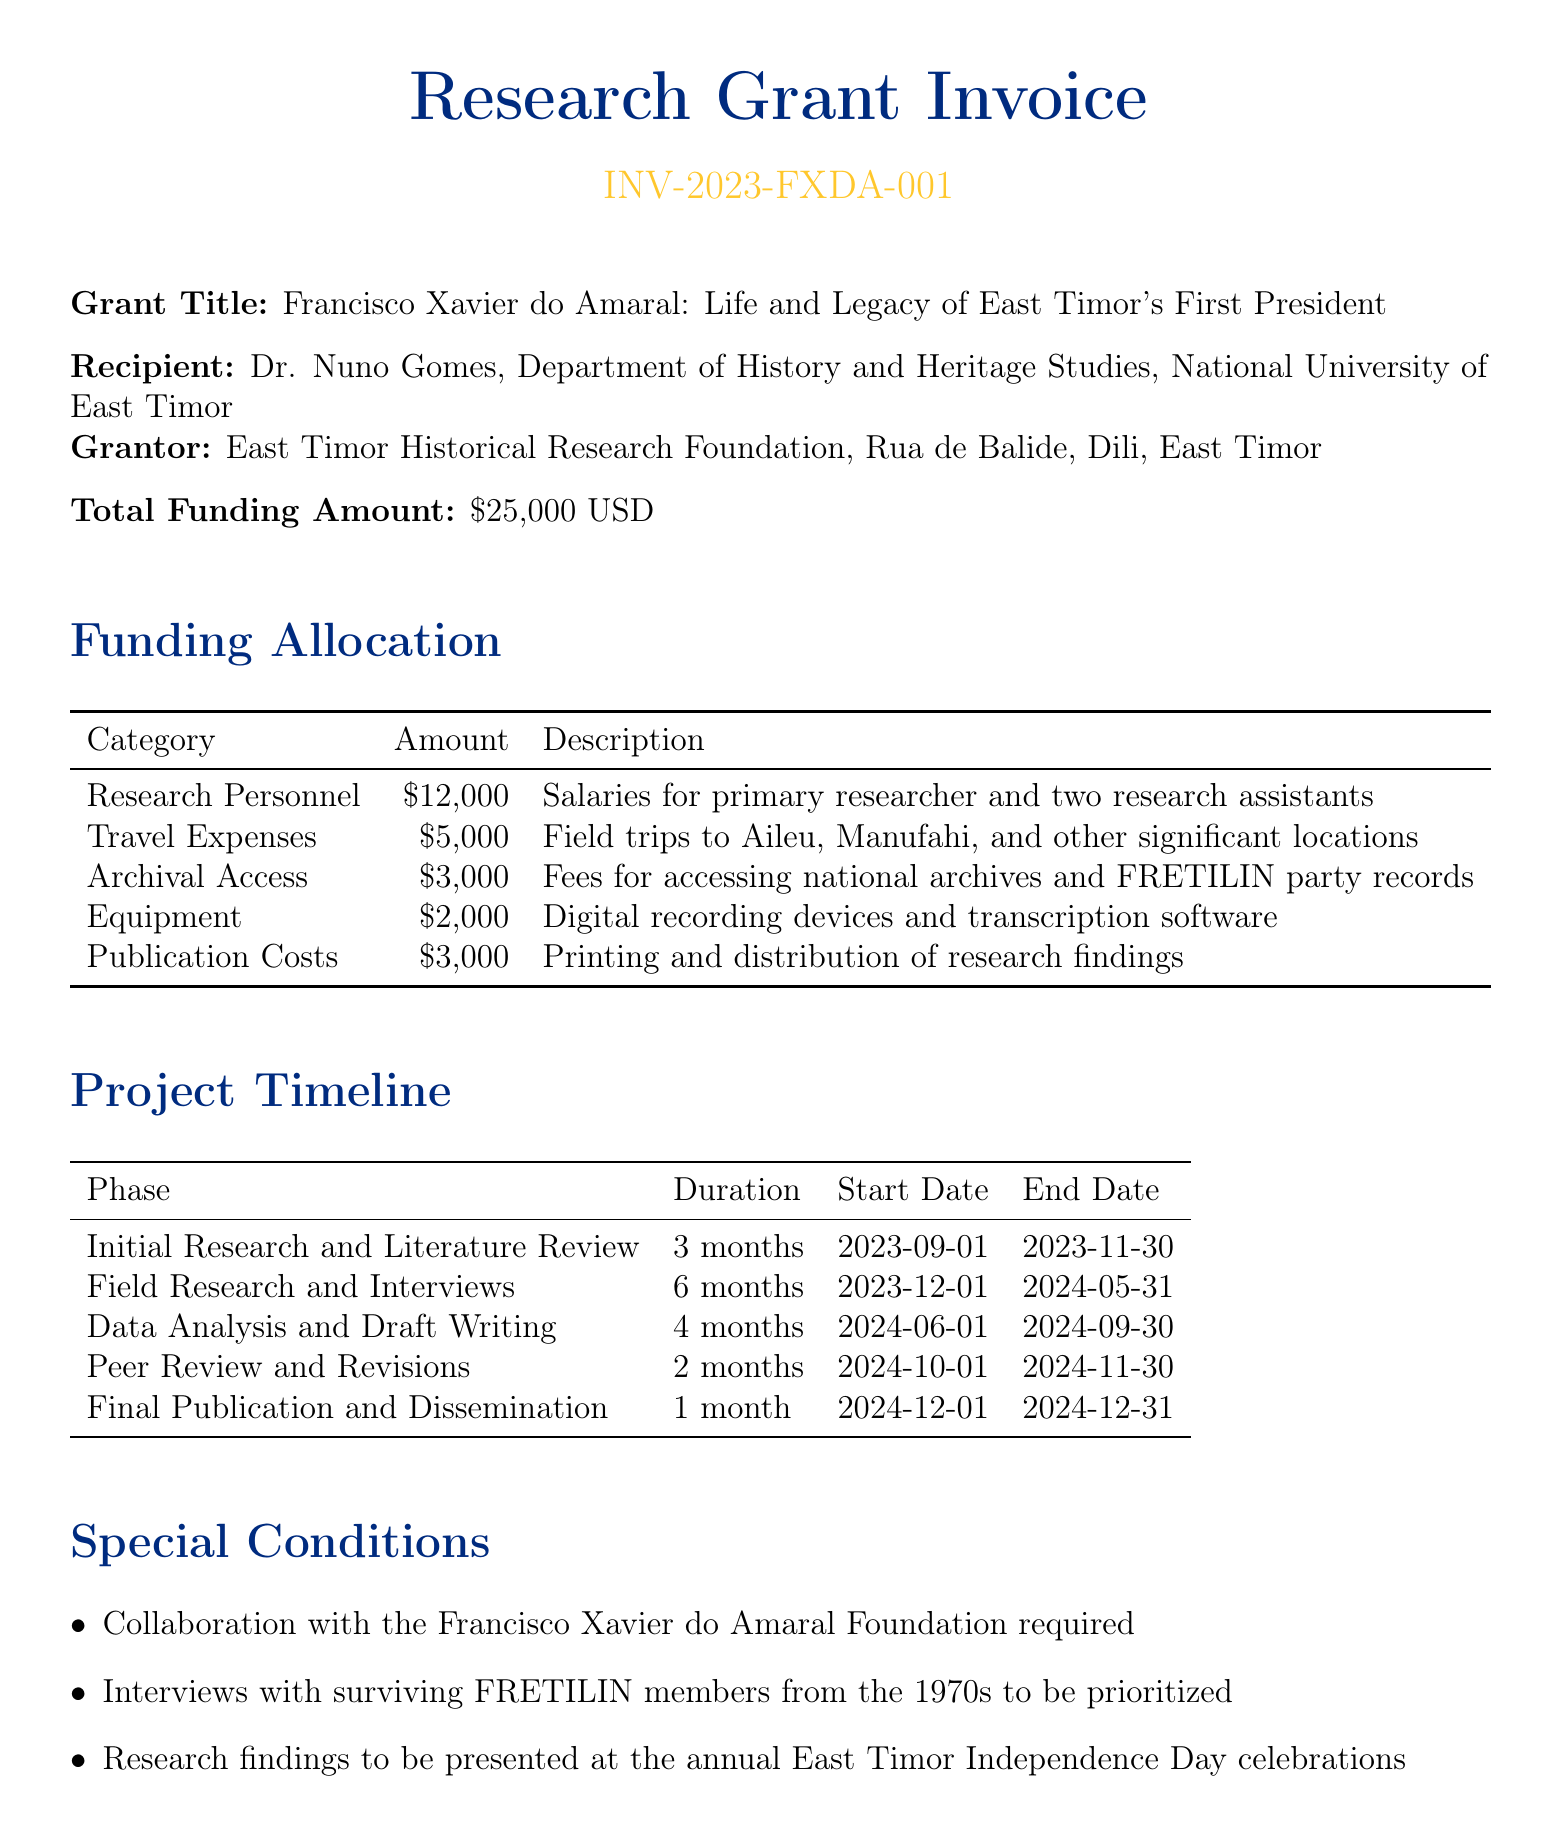What is the invoice number? The invoice number is listed at the top of the document as a unique identifier.
Answer: INV-2023-FXDA-001 Who is the recipient of the grant? The recipient of the grant is mentioned in the document, specifically detailing their name and affiliation.
Answer: Dr. Nuno Gomes What is the total funding amount? The total funding amount is explicitly stated in the document as the sum allocated for the research project.
Answer: $25,000 USD How much is allocated for travel expenses? The funding allocation section provides specific amounts for each category, including travel expenses.
Answer: $5,000 What is the duration of the field research phase? The project timeline section details the duration of each project phase, indicating how long this phase lasts.
Answer: 6 months What needs to be prioritized according to special conditions? The document outlines specific requirements for the research project, including priorities that need to be addressed.
Answer: Interviews with surviving FRETILIN members from the 1970s When is the final payment due? The payment schedule lists all due dates for each installment, including the final one.
Answer: 2024-12-15 What phase follows the data analysis and draft writing? The project timeline indicates the sequence of phases, allowing us to find out which one comes next.
Answer: Peer Review and Revisions What is the total amount allocated for publication costs? This amount is found in the funding allocation, which breaks down the funding by category.
Answer: $3,000 